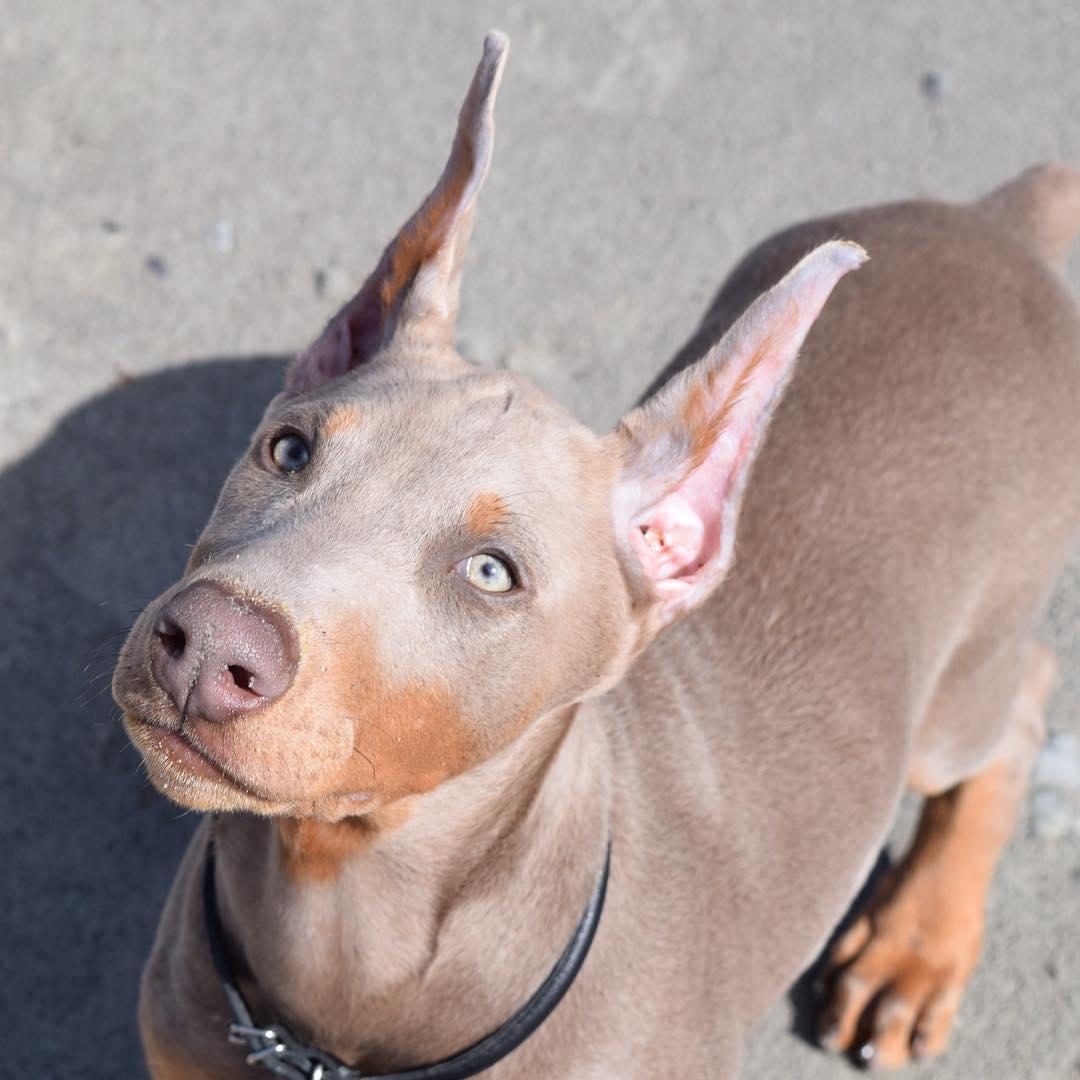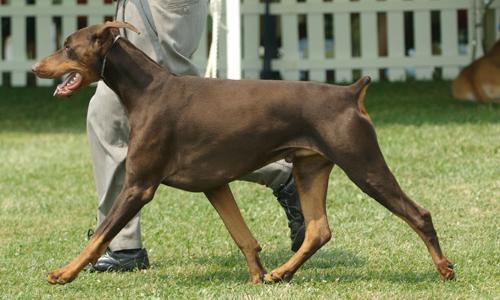The first image is the image on the left, the second image is the image on the right. Evaluate the accuracy of this statement regarding the images: "A dog facing left and is near a man.". Is it true? Answer yes or no. Yes. The first image is the image on the left, the second image is the image on the right. Given the left and right images, does the statement "One image contains one pointy-eared doberman wearing a collar that has pale beige fur with mottled tan spots." hold true? Answer yes or no. Yes. 